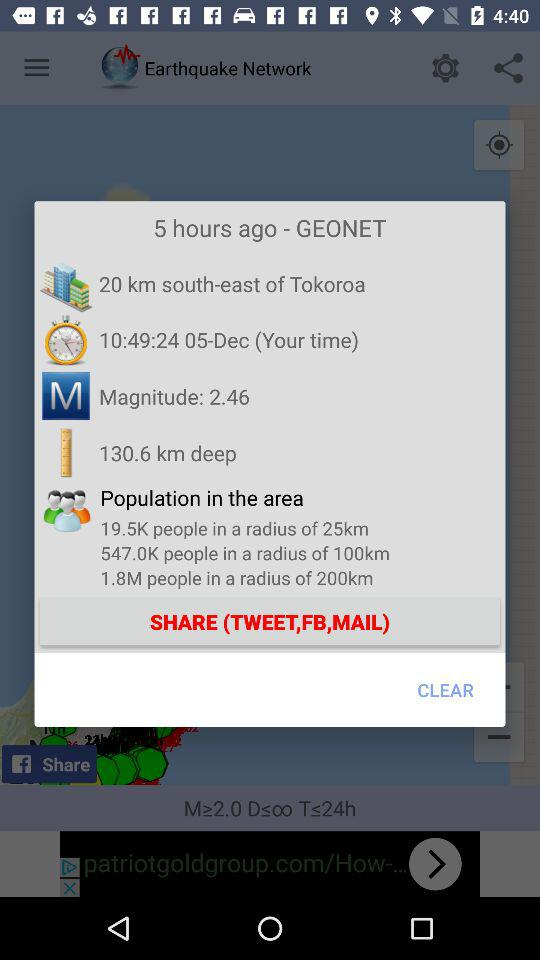How many hours ago was the earthquake?
Answer the question using a single word or phrase. 5 